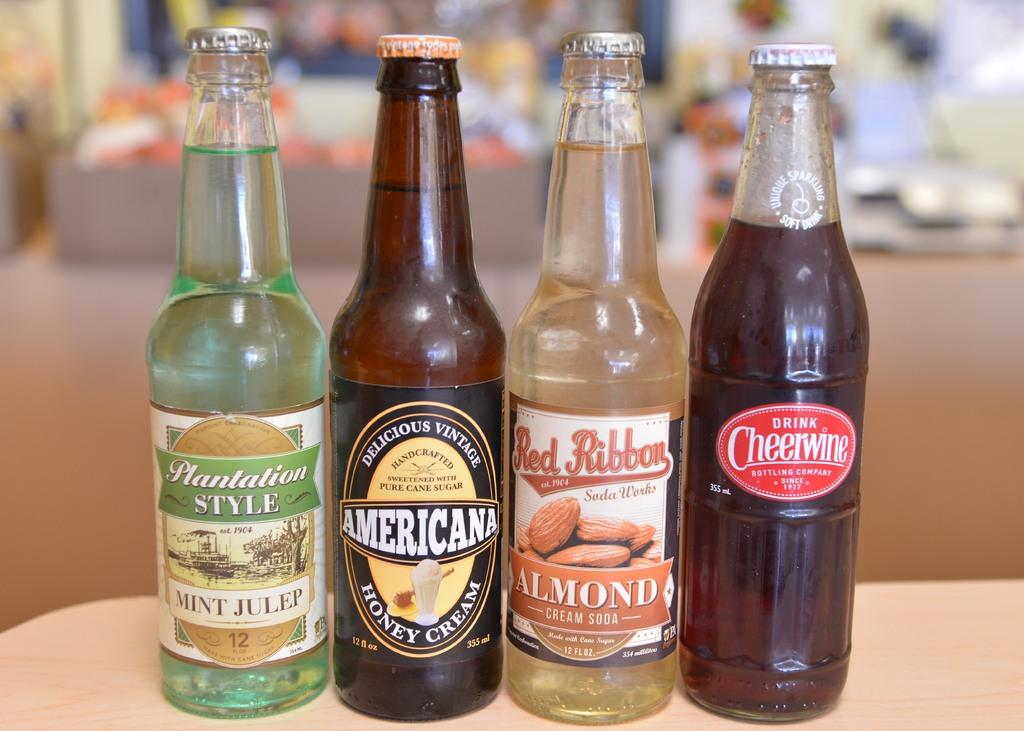<image>
Provide a brief description of the given image. four bottles standing next to each other with one of them labeled 'americana' 